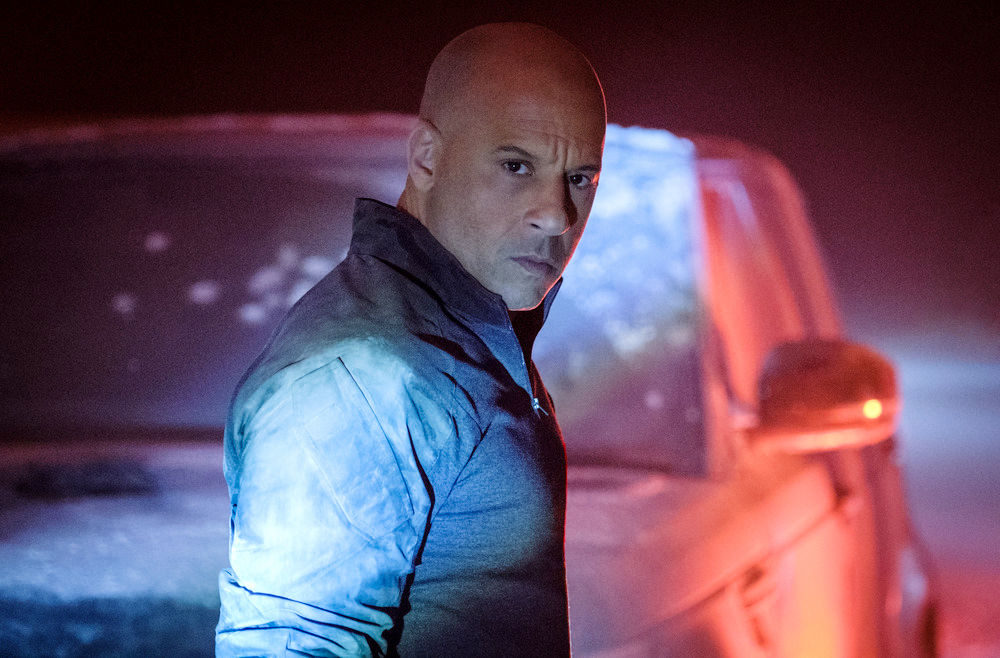Why is the setting of the image dimly lit and foggy? The dimly lit and foggy setting may be designed to evoke a sense of mystery and tension. It could symbolize uncertainty or danger, enhancing the dramatic atmosphere. The fog and low lighting also help to draw attention to the man’s expression and posture, emphasizing his significance within the scene. 